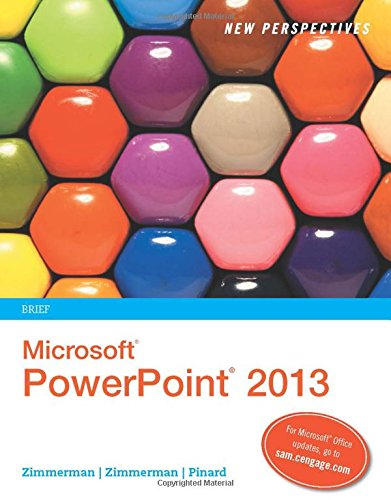Is this book related to Computers & Technology? Yes, this book is intrinsically linked to Computers & Technology, providing insights and educational content on Microsoft PowerPoint 2013. 